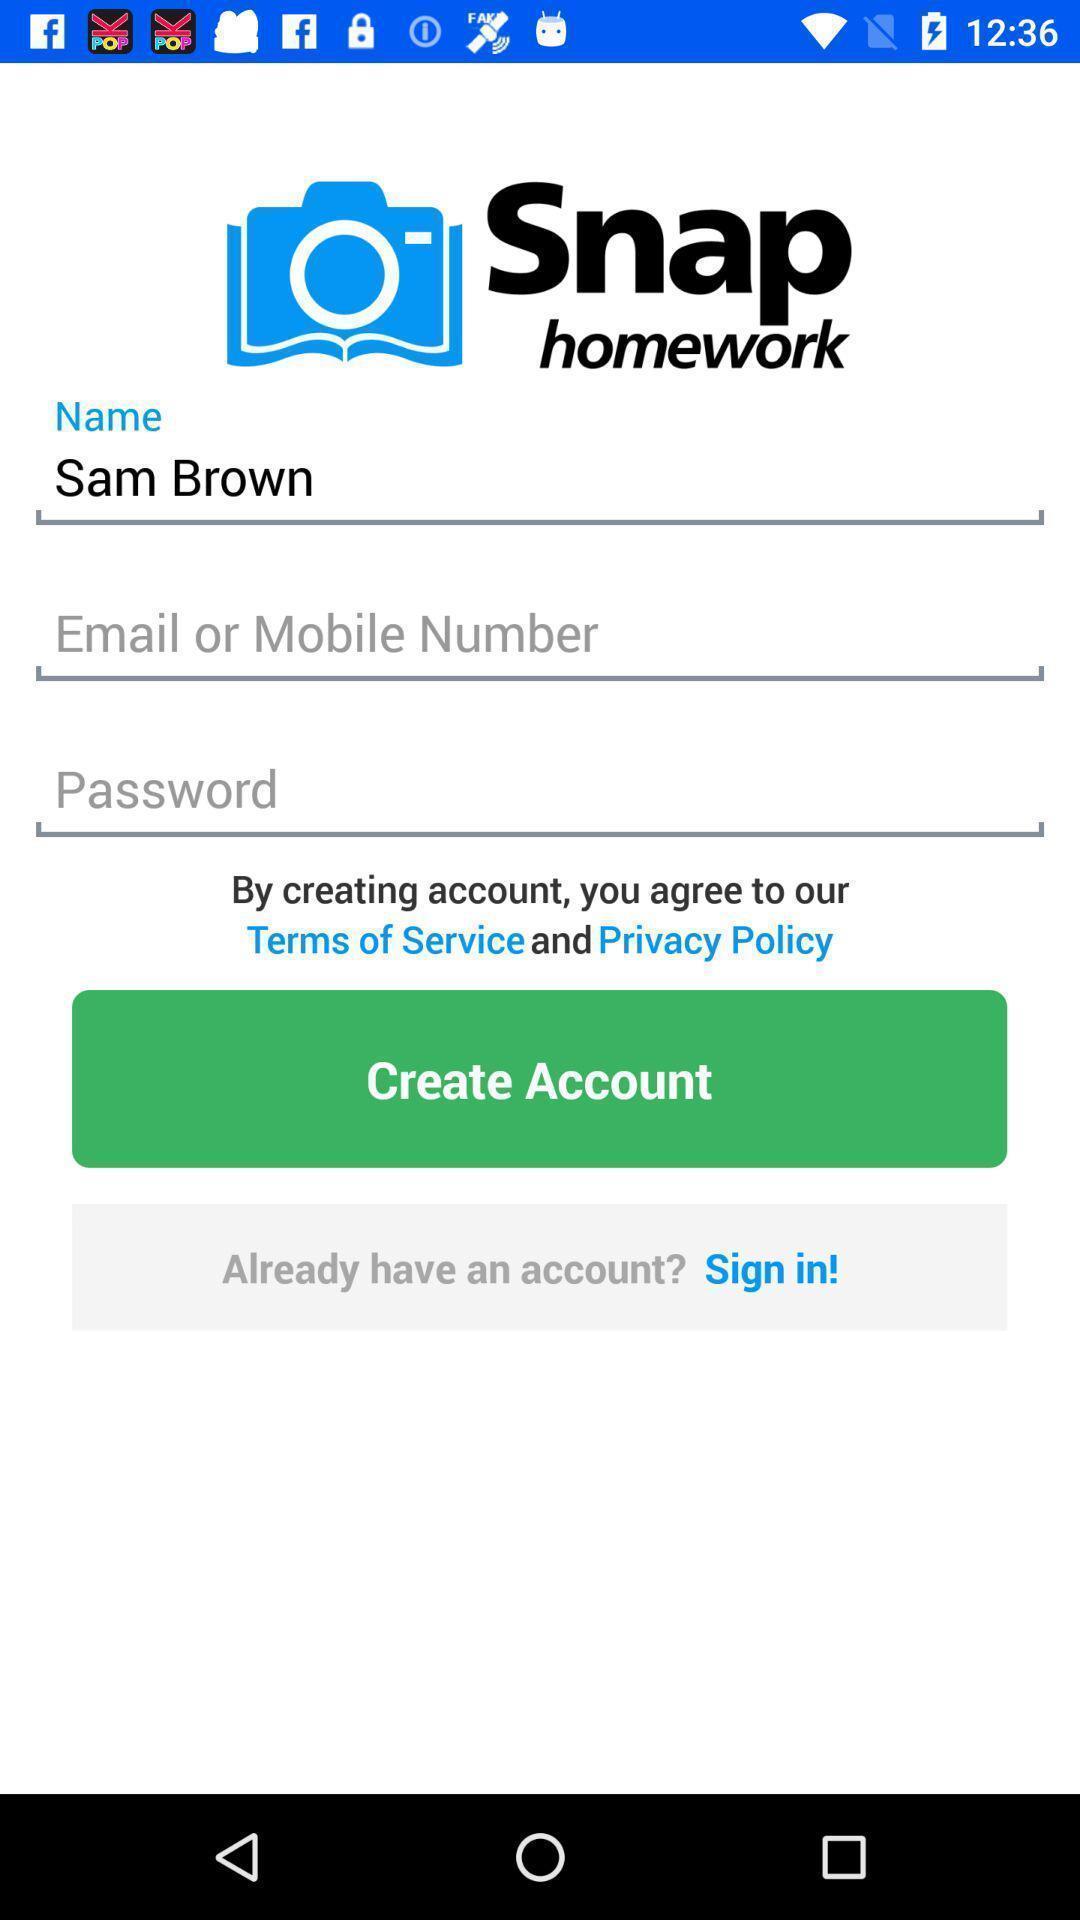Describe the content in this image. Sign in page. 